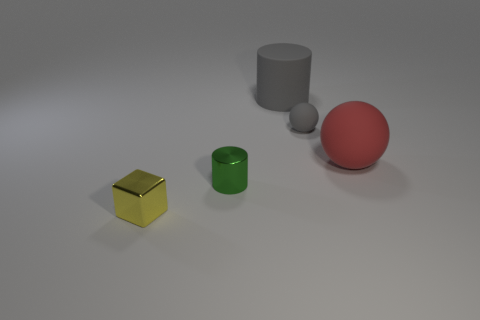Are there any big objects to the left of the red rubber sphere?
Provide a succinct answer. Yes. Are there any big matte cylinders of the same color as the small ball?
Give a very brief answer. Yes. How many large objects are either gray shiny cylinders or green cylinders?
Your answer should be very brief. 0. Does the tiny thing that is in front of the metal cylinder have the same material as the gray sphere?
Your answer should be very brief. No. The gray thing in front of the large matte object that is to the left of the big rubber thing that is in front of the matte cylinder is what shape?
Offer a very short reply. Sphere. What number of purple objects are either shiny cylinders or tiny rubber balls?
Offer a terse response. 0. Are there an equal number of green things to the right of the tiny gray object and spheres right of the tiny yellow thing?
Your answer should be very brief. No. Is the shape of the small metallic thing right of the tiny yellow metallic block the same as the big rubber thing that is to the left of the red rubber object?
Your response must be concise. Yes. Is there anything else that has the same shape as the small yellow metallic thing?
Make the answer very short. No. There is a tiny thing that is the same material as the big red thing; what is its shape?
Your response must be concise. Sphere. 